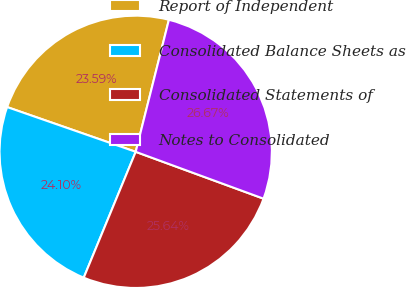Convert chart. <chart><loc_0><loc_0><loc_500><loc_500><pie_chart><fcel>Report of Independent<fcel>Consolidated Balance Sheets as<fcel>Consolidated Statements of<fcel>Notes to Consolidated<nl><fcel>23.59%<fcel>24.1%<fcel>25.64%<fcel>26.67%<nl></chart> 